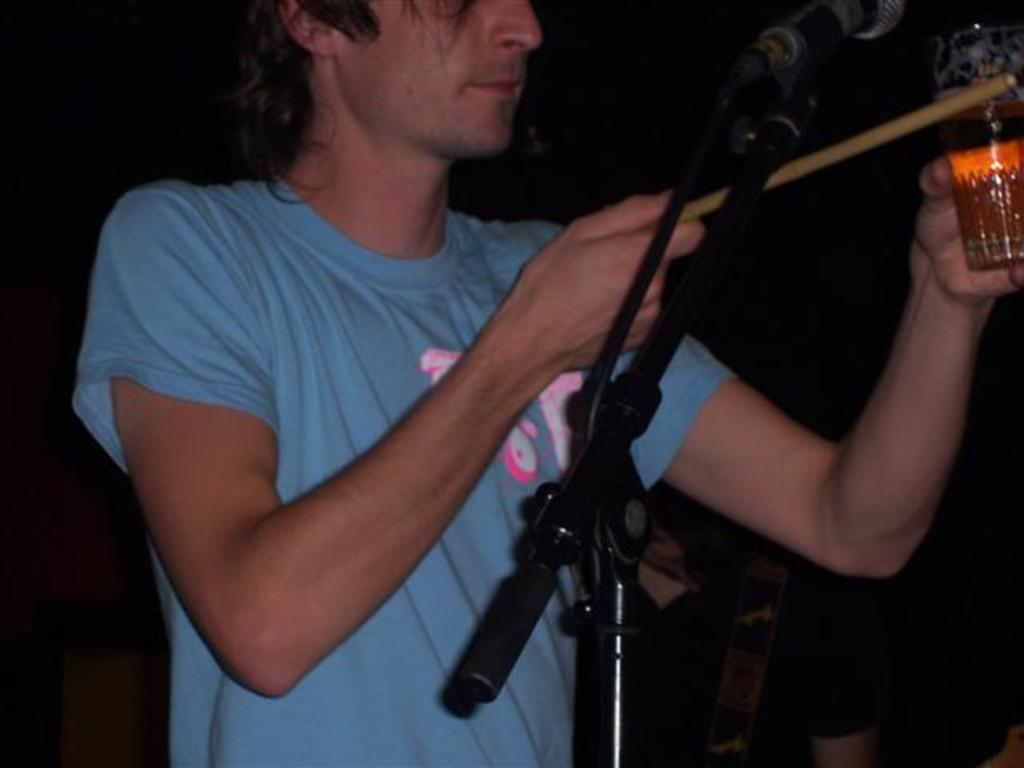What is the man in the image wearing? The man is wearing a blue t-shirt. What is the man holding in his hands? The man is holding a glass in his hands. What is the man doing with the glass? The man is looking at the glass. What is in front of the man? There is a microphone stand in front of the man. What is the man holding in addition to the glass? The man is also holding a stick. What type of zebra can be seen in the image? There is no zebra present in the image. Is the man wearing a cast on his arm in the image? There is there any indication of an injury? 